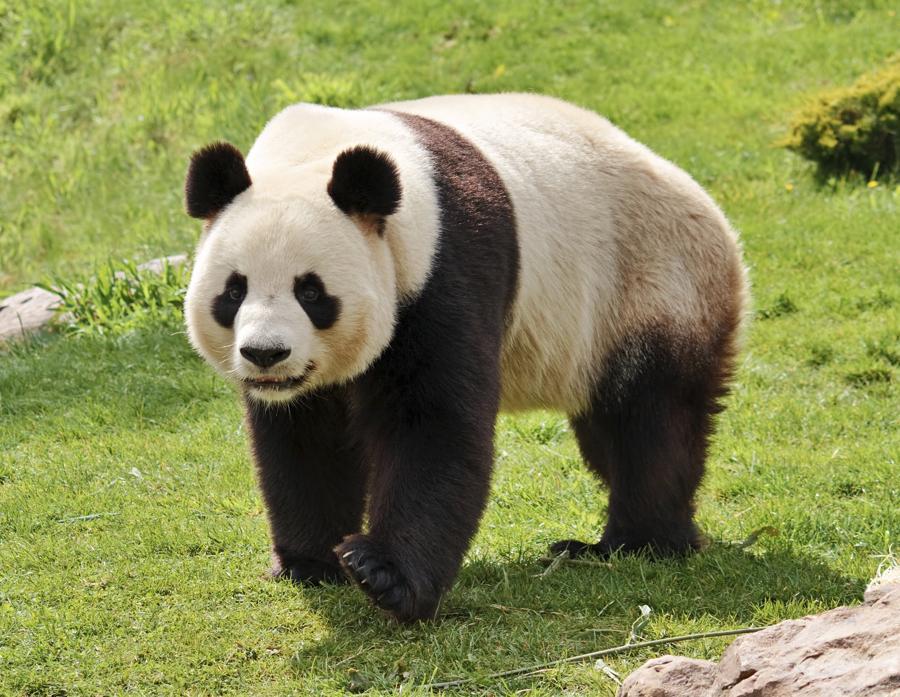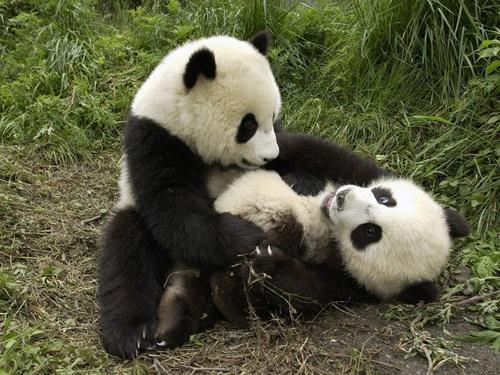The first image is the image on the left, the second image is the image on the right. Evaluate the accuracy of this statement regarding the images: "The lefthand image contains one panda, which is holding a green stalk.". Is it true? Answer yes or no. No. The first image is the image on the left, the second image is the image on the right. Evaluate the accuracy of this statement regarding the images: "The panda in the left image has a bamboo stock in their hand.". Is it true? Answer yes or no. No. 